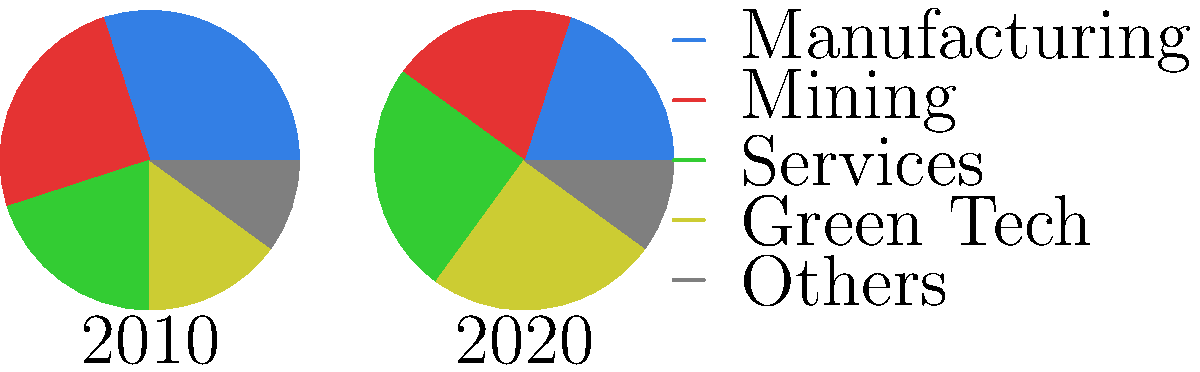The pie charts show the employment rates in various sectors for the years 2010 and 2020. Which sector experienced the most significant growth in employment share, and how does this trend align with traditional industrial policies? To answer this question, we need to compare the employment shares for each sector between 2010 and 2020:

1. Manufacturing: Decreased from 30% to 20%
2. Mining: Decreased from 25% to 20%
3. Services: Increased from 20% to 25%
4. Green Tech: Increased from 15% to 25%
5. Others: Remained constant at 10%

The sector that experienced the most significant growth in employment share is Green Tech, increasing from 15% to 25% (a 10 percentage point increase).

This trend does not align well with traditional industrial policies, which typically focus on sectors like manufacturing and mining. The data shows that these traditional sectors have actually decreased in employment share:
- Manufacturing decreased by 10 percentage points
- Mining decreased by 5 percentage points

The growth in Green Tech employment contradicts the belief that focusing on green technologies is a waste of resources. Instead, it suggests that green technologies are becoming an increasingly important part of the economy and job market.

However, it's worth noting that the Services sector also experienced growth, increasing by 5 percentage points. This could be seen as a more neutral development, neither strongly supporting nor contradicting traditional industrial policies.
Answer: Green Tech sector grew most (10%), misaligning with traditional industrial policies. 